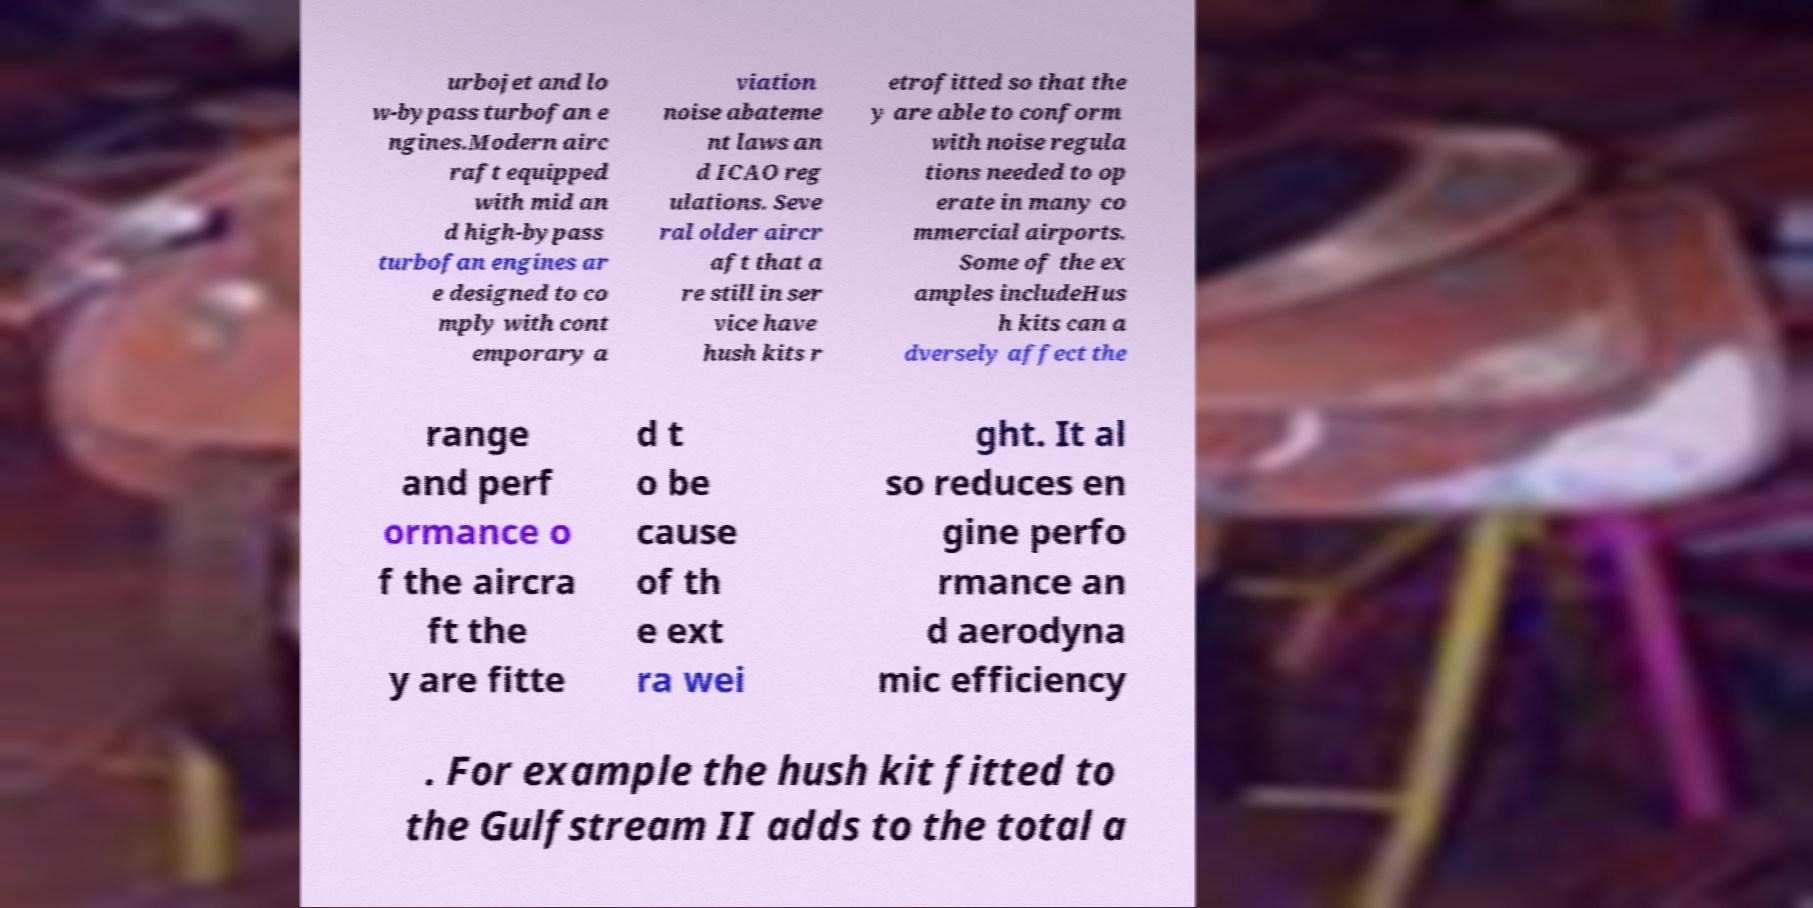Could you extract and type out the text from this image? urbojet and lo w-bypass turbofan e ngines.Modern airc raft equipped with mid an d high-bypass turbofan engines ar e designed to co mply with cont emporary a viation noise abateme nt laws an d ICAO reg ulations. Seve ral older aircr aft that a re still in ser vice have hush kits r etrofitted so that the y are able to conform with noise regula tions needed to op erate in many co mmercial airports. Some of the ex amples includeHus h kits can a dversely affect the range and perf ormance o f the aircra ft the y are fitte d t o be cause of th e ext ra wei ght. It al so reduces en gine perfo rmance an d aerodyna mic efficiency . For example the hush kit fitted to the Gulfstream II adds to the total a 